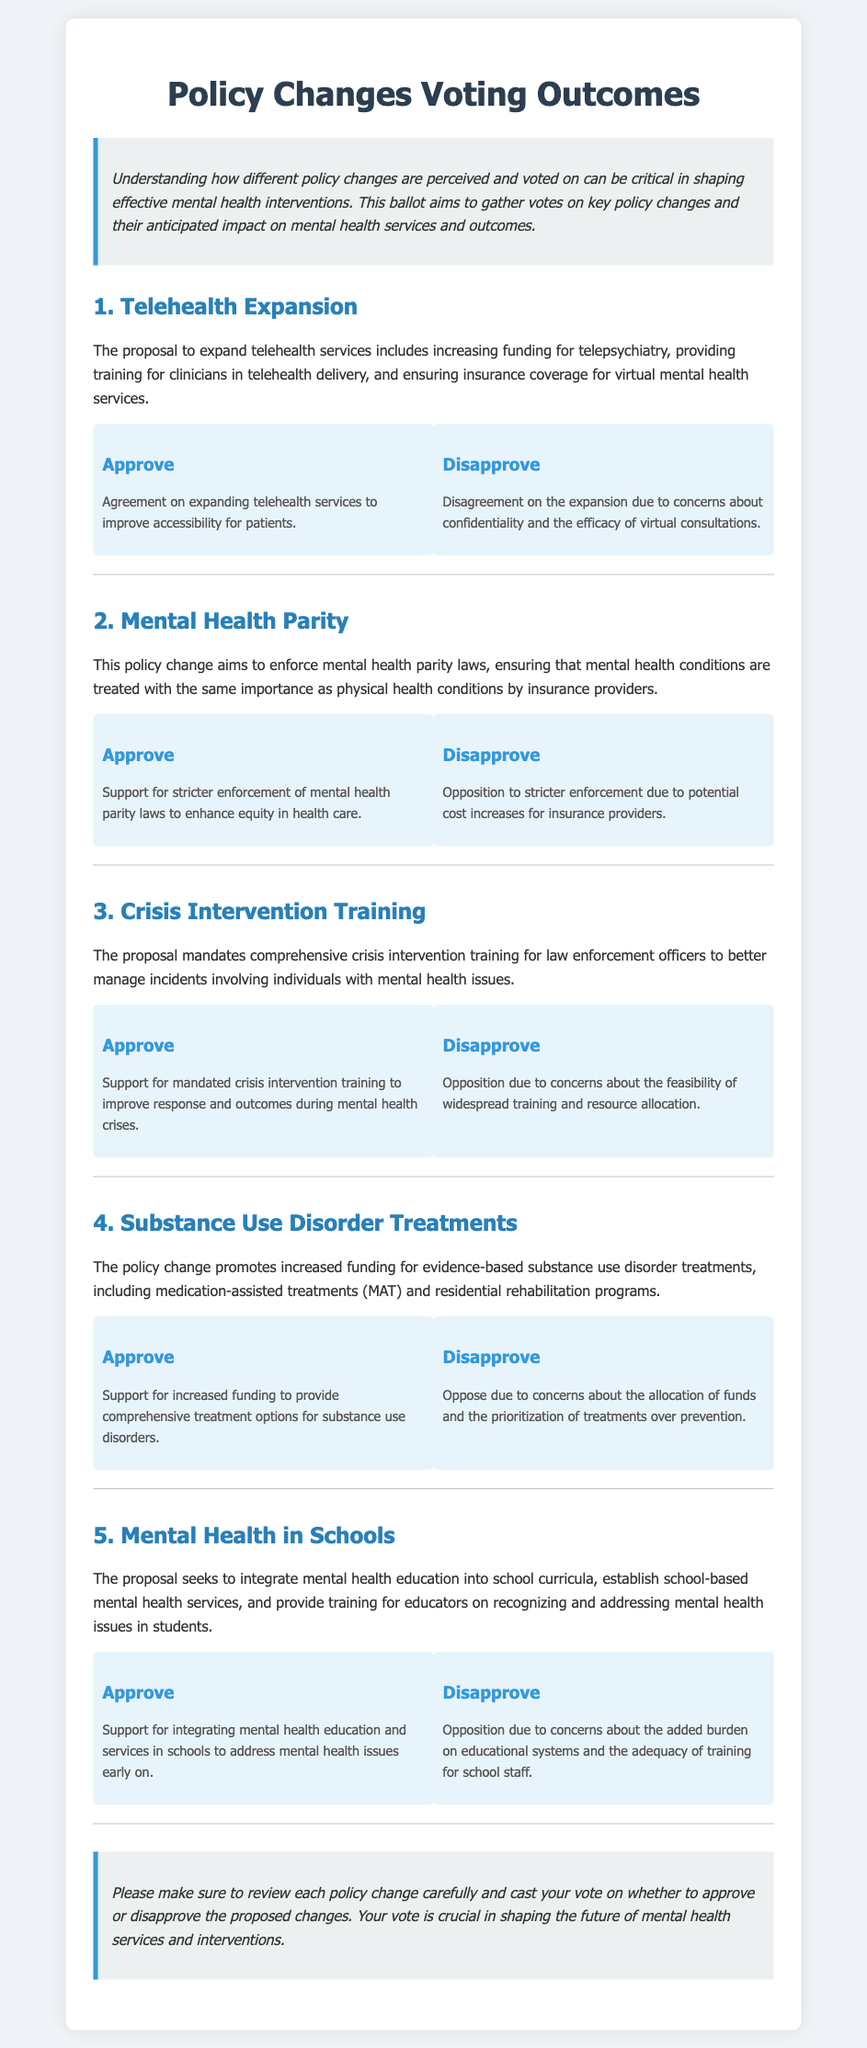What is the title of the document? The title is prominently displayed at the top of the document, indicating the focus on voting outcomes related to policies.
Answer: Policy Changes Voting Outcomes What is the proposal regarding Telehealth Expansion? The proposal includes increasing funding for telepsychiatry and ensuring insurance coverage for virtual mental health services.
Answer: Expand telehealth services What policy change aims to enforce mental health parity laws? This change ensures that mental health conditions are treated with the same importance as physical health conditions by insurance providers.
Answer: Mental Health Parity How many sections are there in the document? The document contains a total of five sections, each addressing a different policy proposal.
Answer: Five What is a concern regarding the Crisis Intervention Training proposal? A concern raised involves the feasibility of widespread training and resource allocation for law enforcement.
Answer: Feasibility of training What is the proposed approach to mental health in schools? The proposal seeks to integrate mental health education into school curricula and establish school-based services.
Answer: Integrate mental health education What are the two voting options presented for each policy change? Each policy change offers the option to either approve or disapprove the proposal.
Answer: Approve and Disapprove What is a reason to disapprove the Substance Use Disorder Treatments funding increase? Concerns about the prioritization of treatments over prevention have been cited as a reason for disapproval.
Answer: Allocation of funds What is the purpose of the introduction in the document? The introduction outlines the importance of understanding policy changes' impacts on mental health interventions.
Answer: Gather votes on key policy changes 